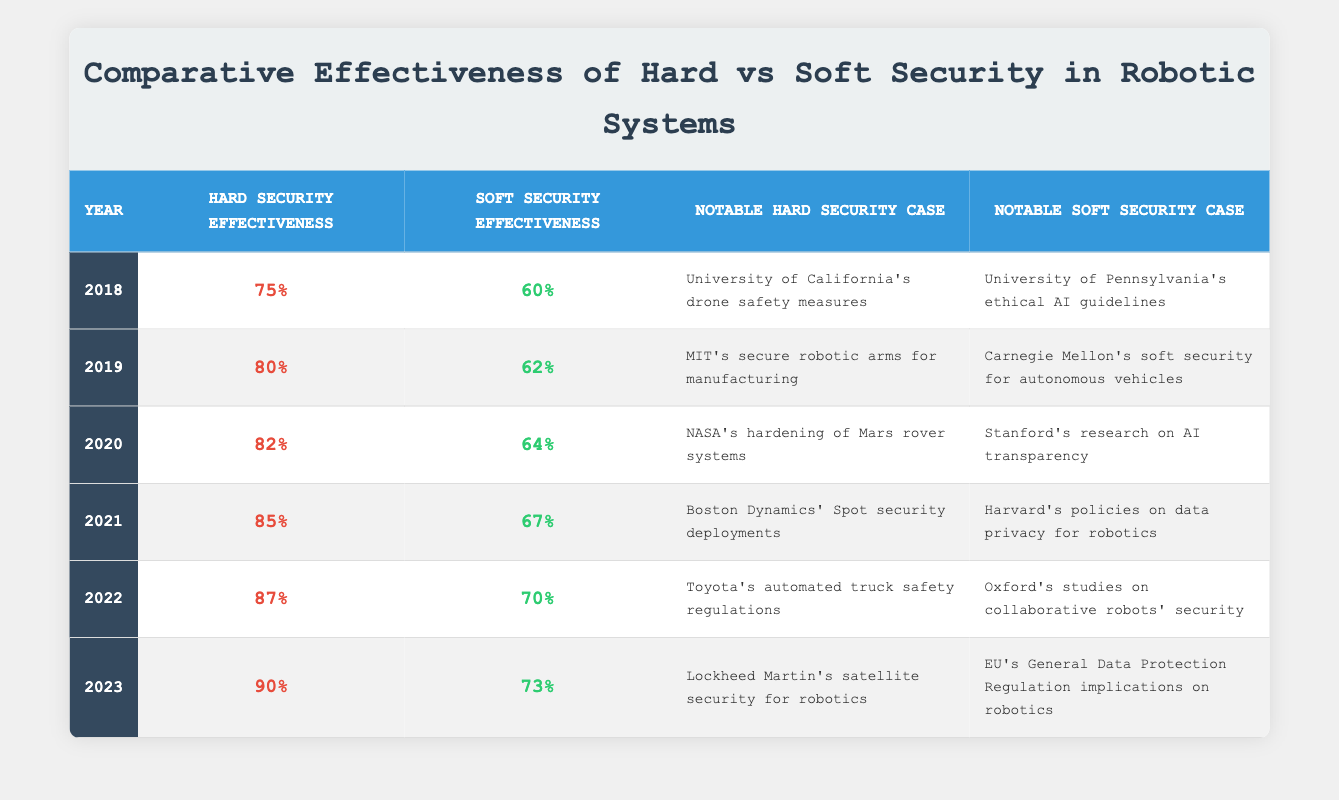What was the hard security effectiveness in 2020? The table shows that the hard security effectiveness in 2020 is listed as 82%.
Answer: 82% What notable hard security case is mentioned for 2022? According to the table, the notable hard security case for 2022 is "Toyota's automated truck safety regulations".
Answer: Toyota's automated truck safety regulations How much did the soft security effectiveness increase from 2018 to 2023? The soft security effectiveness in 2018 is 60% and in 2023 it is 73%. The increase can be calculated as 73 - 60 = 13%.
Answer: 13% Was the effectiveness of hard security greater than soft security in 2021? In 2021, the hard security effectiveness is 85% while the soft security effectiveness is 67%, showing that hard security was greater.
Answer: Yes What is the average hard security effectiveness over the years presented? The hard security effectiveness values are 75, 80, 82, 85, 87, and 90. Summing these gives 75 + 80 + 82 + 85 + 87 + 90 = 509. There are 6 years, so the average is 509 / 6 = 84.83.
Answer: 84.83 How does the soft security effectiveness in 2019 compare to that in 2021? The soft security effectiveness in 2019 is 62% and in 2021 it is 67%. Comparing these values shows that 67 is greater than 62.
Answer: 67 is greater than 62 What year saw the most significant improvement in hard security effectiveness compared to the previous year? To find this, we can compare the differences year by year: 2018 to 2019 (80-75=5), 2019 to 2020 (82-80=2), 2020 to 2021 (85-82=3), 2021 to 2022 (87-85=2), and 2022 to 2023 (90-87=3). The largest increase is 5 from 2018 to 2019.
Answer: 2018 to 2019 Which notable soft security case is associated with the year 2020? The notable soft security case in 2020, as stated in the table, is "Stanford's research on AI transparency".
Answer: Stanford's research on AI transparency 